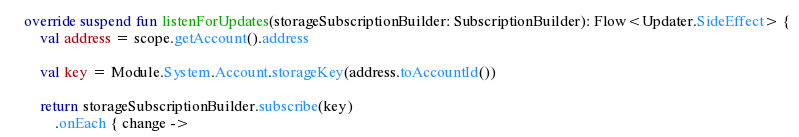<code> <loc_0><loc_0><loc_500><loc_500><_Kotlin_>    override suspend fun listenForUpdates(storageSubscriptionBuilder: SubscriptionBuilder): Flow<Updater.SideEffect> {
        val address = scope.getAccount().address

        val key = Module.System.Account.storageKey(address.toAccountId())

        return storageSubscriptionBuilder.subscribe(key)
            .onEach { change -></code> 